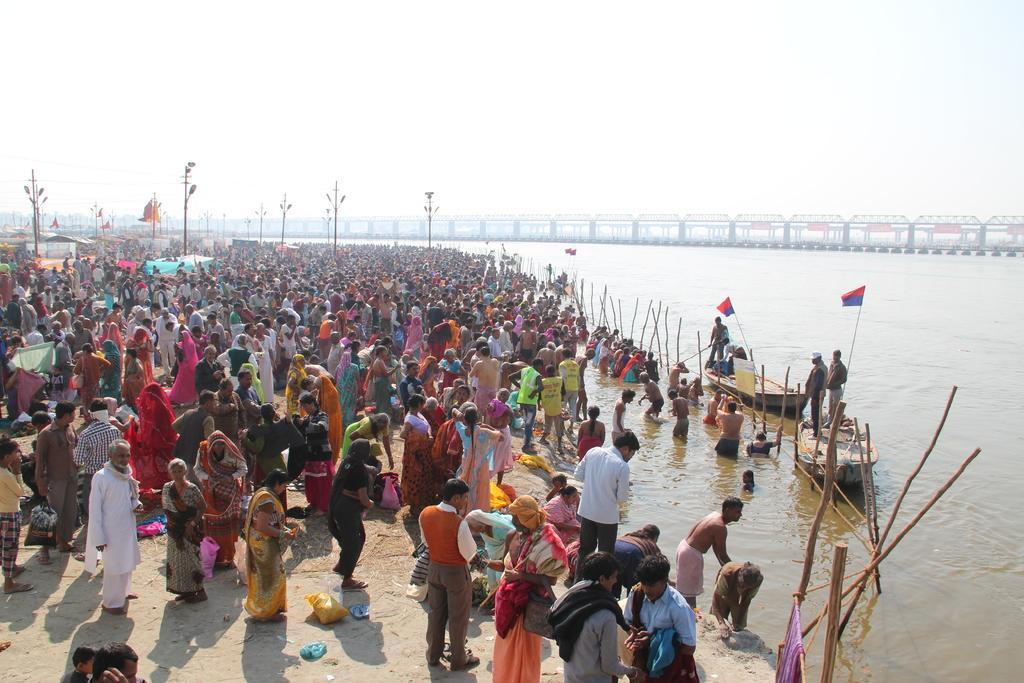Please provide a concise description of this image. In this image I can see the ground, number of persons standing on the ground, few poles, few lights, few wires, few boats, few flags the water and a bridge. In the background I can see the sky. 